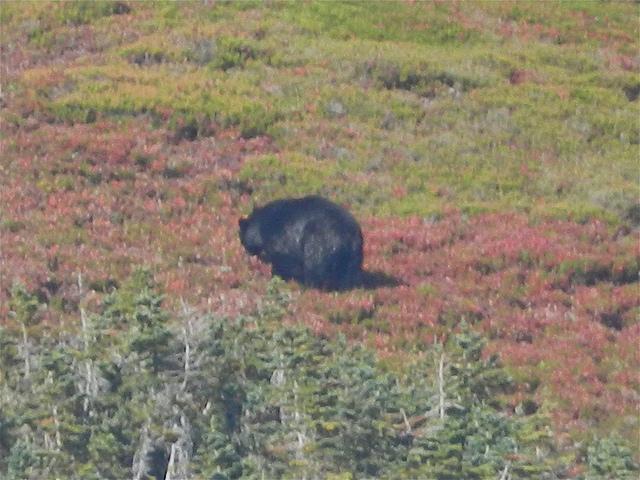What color is the bear?
Quick response, please. Black. In what region do most bears live in?
Be succinct. North america. What type of animal is in the picture?
Give a very brief answer. Bear. Can you see the face of this animal?
Keep it brief. No. 